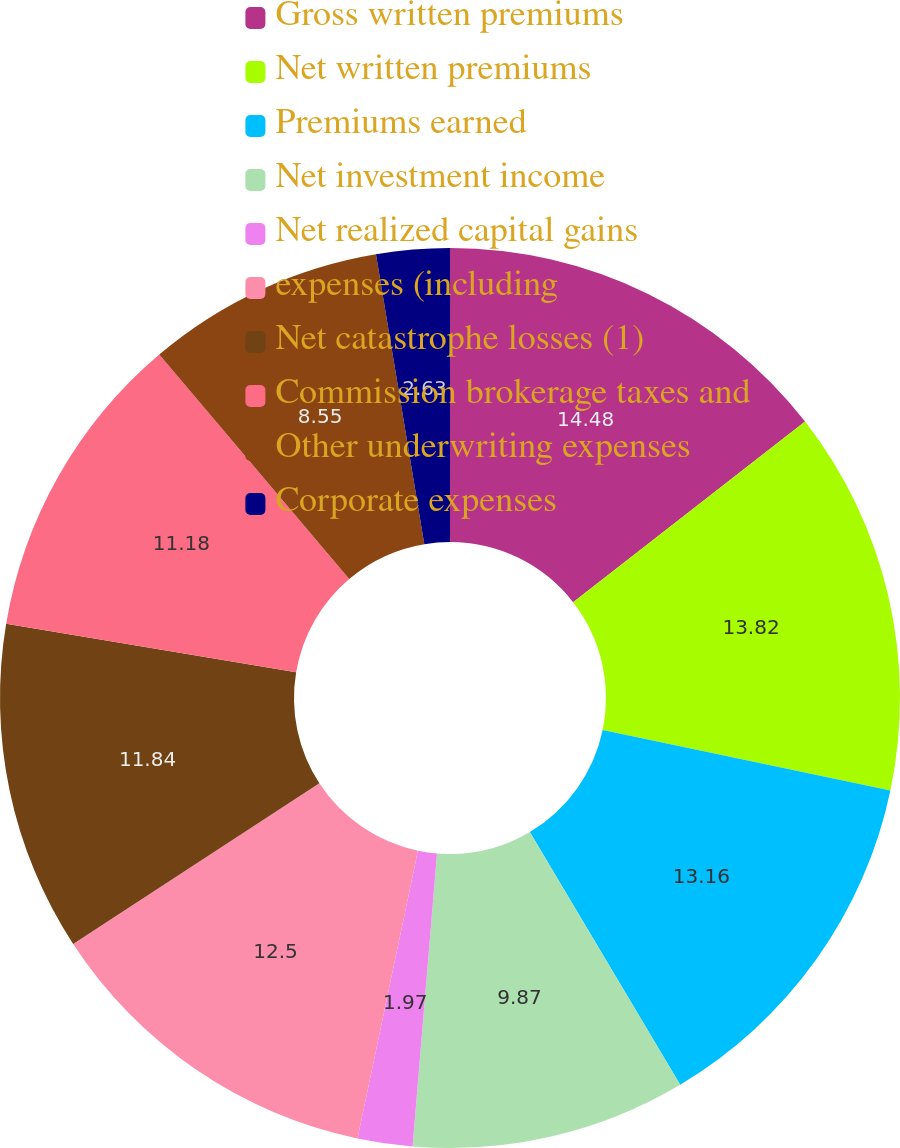Convert chart. <chart><loc_0><loc_0><loc_500><loc_500><pie_chart><fcel>Gross written premiums<fcel>Net written premiums<fcel>Premiums earned<fcel>Net investment income<fcel>Net realized capital gains<fcel>expenses (including<fcel>Net catastrophe losses (1)<fcel>Commission brokerage taxes and<fcel>Other underwriting expenses<fcel>Corporate expenses<nl><fcel>14.47%<fcel>13.82%<fcel>13.16%<fcel>9.87%<fcel>1.97%<fcel>12.5%<fcel>11.84%<fcel>11.18%<fcel>8.55%<fcel>2.63%<nl></chart> 